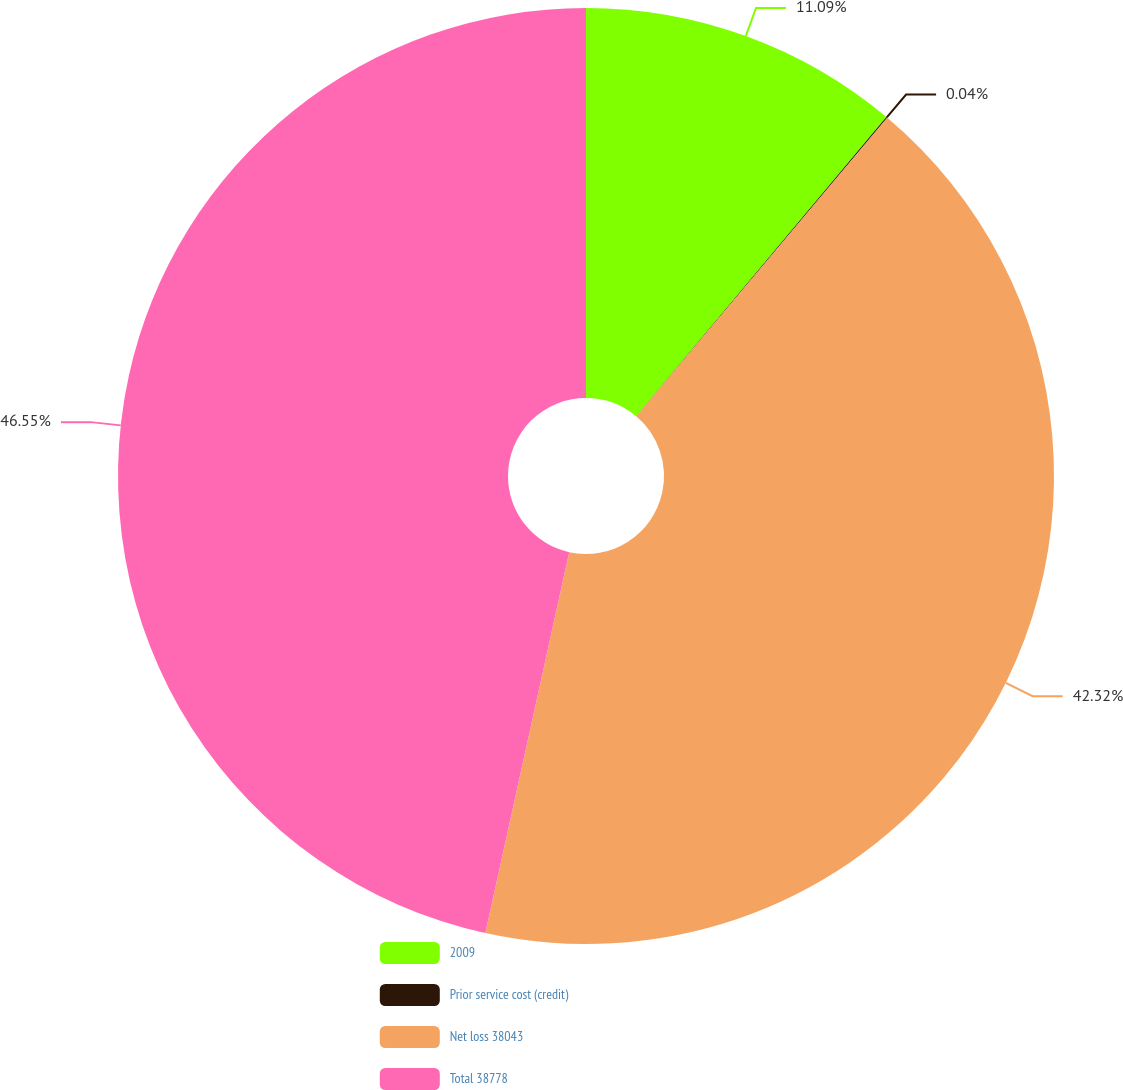Convert chart to OTSL. <chart><loc_0><loc_0><loc_500><loc_500><pie_chart><fcel>2009<fcel>Prior service cost (credit)<fcel>Net loss 38043<fcel>Total 38778<nl><fcel>11.09%<fcel>0.04%<fcel>42.32%<fcel>46.55%<nl></chart> 